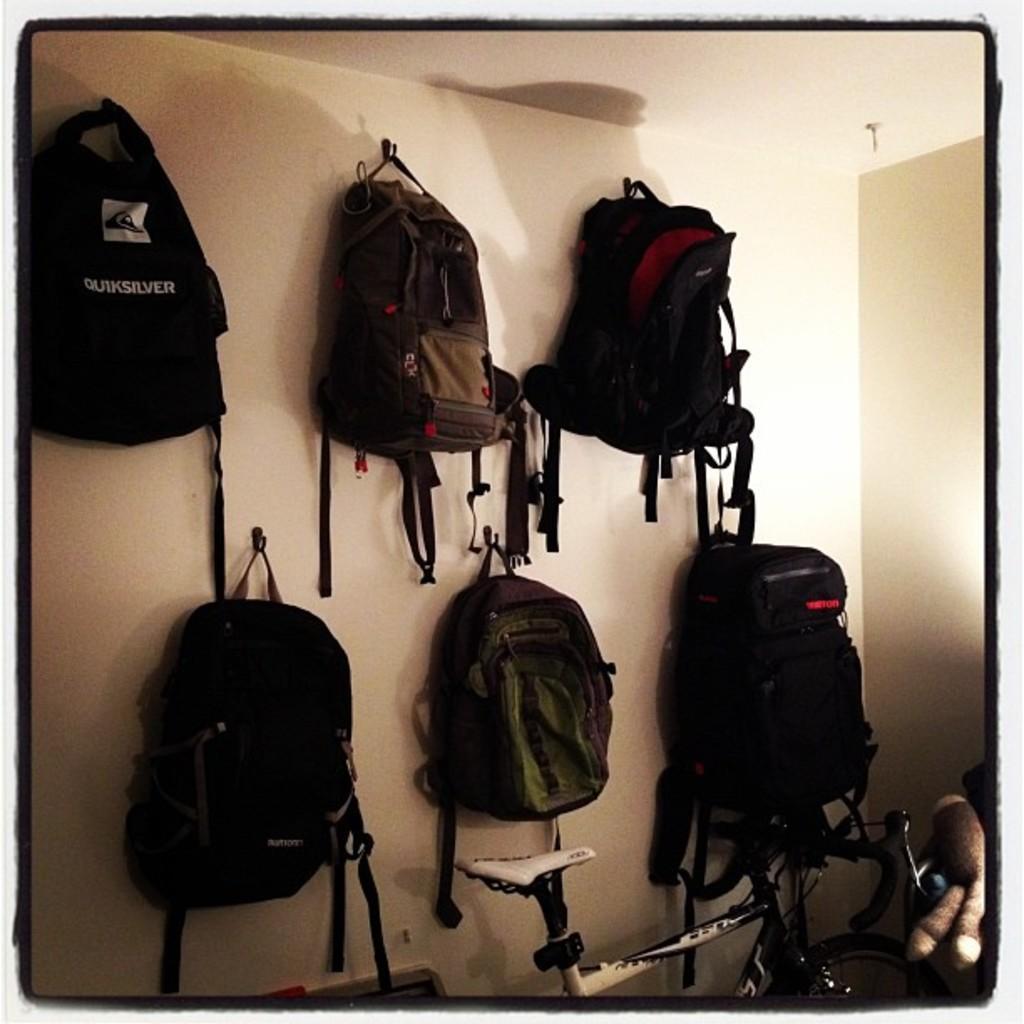Could you give a brief overview of what you see in this image? In this image we can see some bags hanged on a wall. We can also see a toy and a bicycle. 